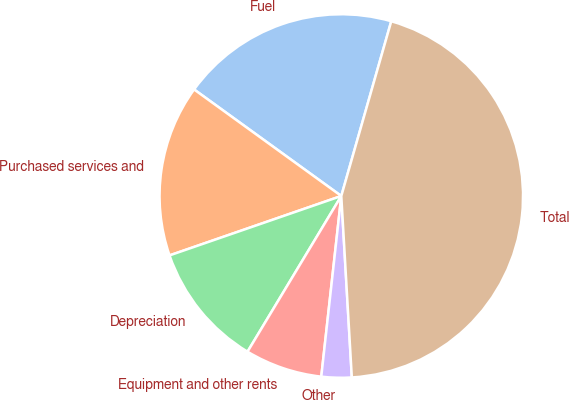Convert chart to OTSL. <chart><loc_0><loc_0><loc_500><loc_500><pie_chart><fcel>Fuel<fcel>Purchased services and<fcel>Depreciation<fcel>Equipment and other rents<fcel>Other<fcel>Total<nl><fcel>19.46%<fcel>15.27%<fcel>11.07%<fcel>6.87%<fcel>2.68%<fcel>44.64%<nl></chart> 